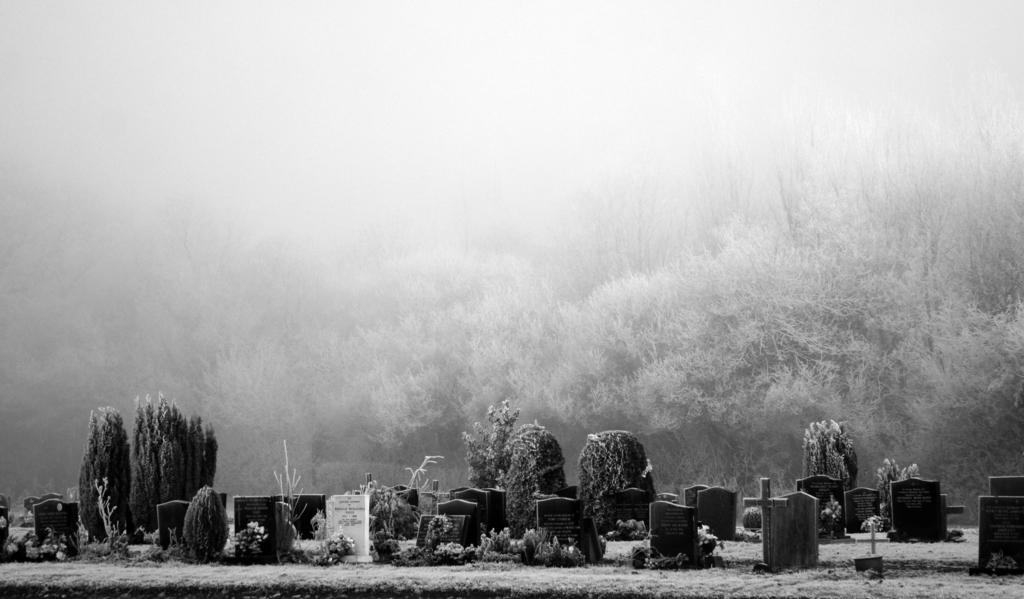What can be found at the bottom of the image? There are graves at the bottom of the image, along with plants and grass. What religious symbol is present in the image? There is a cross mark in the image. What type of vegetation is present at the bottom of the image? Plants and grass are visible at the bottom of the image. What is visible in the background of the image? There are many trees in the background of the image. What is the weather condition at the top of the image? There is fog or snow at the top of the image. How many cats are sitting on the line in the image? There are no cats or lines present in the image. 